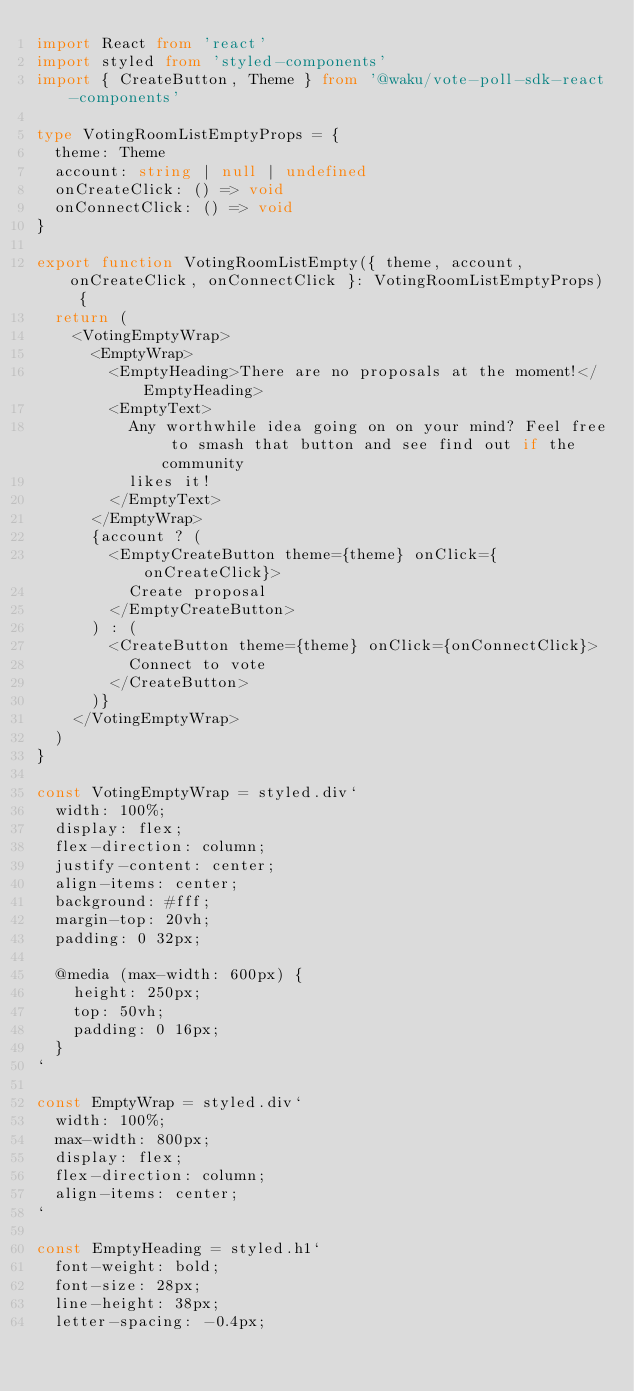Convert code to text. <code><loc_0><loc_0><loc_500><loc_500><_TypeScript_>import React from 'react'
import styled from 'styled-components'
import { CreateButton, Theme } from '@waku/vote-poll-sdk-react-components'

type VotingRoomListEmptyProps = {
  theme: Theme
  account: string | null | undefined
  onCreateClick: () => void
  onConnectClick: () => void
}

export function VotingRoomListEmpty({ theme, account, onCreateClick, onConnectClick }: VotingRoomListEmptyProps) {
  return (
    <VotingEmptyWrap>
      <EmptyWrap>
        <EmptyHeading>There are no proposals at the moment!</EmptyHeading>
        <EmptyText>
          Any worthwhile idea going on on your mind? Feel free to smash that button and see find out if the community
          likes it!
        </EmptyText>
      </EmptyWrap>
      {account ? (
        <EmptyCreateButton theme={theme} onClick={onCreateClick}>
          Create proposal
        </EmptyCreateButton>
      ) : (
        <CreateButton theme={theme} onClick={onConnectClick}>
          Connect to vote
        </CreateButton>
      )}
    </VotingEmptyWrap>
  )
}

const VotingEmptyWrap = styled.div`
  width: 100%;
  display: flex;
  flex-direction: column;
  justify-content: center;
  align-items: center;
  background: #fff;
  margin-top: 20vh;
  padding: 0 32px;

  @media (max-width: 600px) {
    height: 250px;
    top: 50vh;
    padding: 0 16px;
  }
`

const EmptyWrap = styled.div`
  width: 100%;
  max-width: 800px;
  display: flex;
  flex-direction: column;
  align-items: center;
`

const EmptyHeading = styled.h1`
  font-weight: bold;
  font-size: 28px;
  line-height: 38px;
  letter-spacing: -0.4px;</code> 